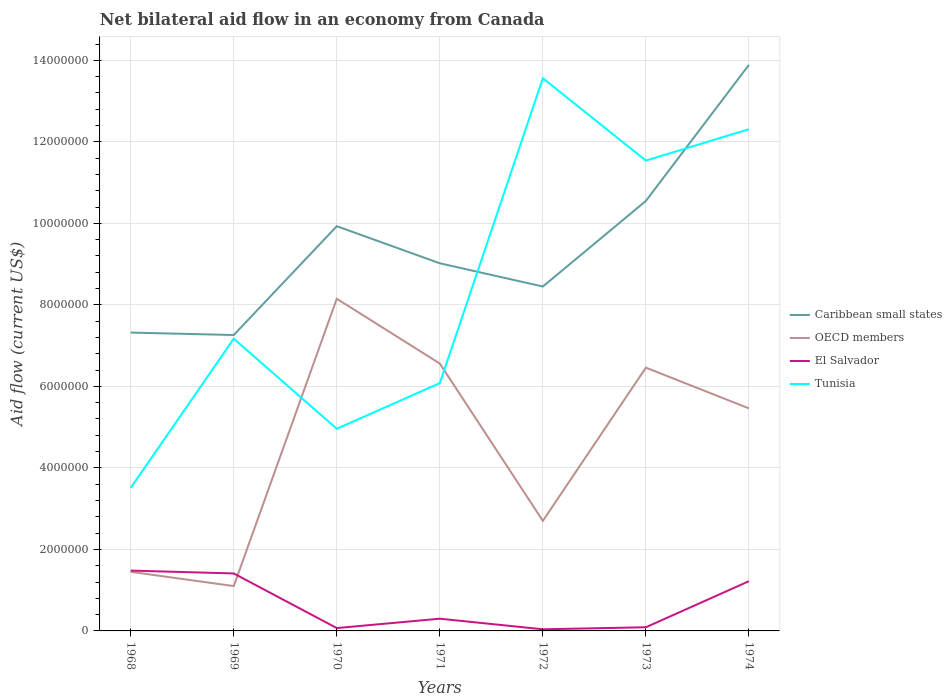How many different coloured lines are there?
Your answer should be very brief. 4. Does the line corresponding to El Salvador intersect with the line corresponding to Tunisia?
Your answer should be compact. No. Is the number of lines equal to the number of legend labels?
Give a very brief answer. Yes. Across all years, what is the maximum net bilateral aid flow in Tunisia?
Provide a succinct answer. 3.51e+06. In which year was the net bilateral aid flow in Tunisia maximum?
Make the answer very short. 1968. What is the total net bilateral aid flow in OECD members in the graph?
Provide a succinct answer. 1.00e+06. What is the difference between the highest and the second highest net bilateral aid flow in OECD members?
Provide a short and direct response. 7.05e+06. What is the difference between the highest and the lowest net bilateral aid flow in Caribbean small states?
Provide a short and direct response. 3. What is the difference between two consecutive major ticks on the Y-axis?
Your answer should be compact. 2.00e+06. Does the graph contain grids?
Offer a terse response. Yes. What is the title of the graph?
Give a very brief answer. Net bilateral aid flow in an economy from Canada. What is the label or title of the Y-axis?
Give a very brief answer. Aid flow (current US$). What is the Aid flow (current US$) of Caribbean small states in 1968?
Ensure brevity in your answer.  7.32e+06. What is the Aid flow (current US$) in OECD members in 1968?
Your answer should be very brief. 1.45e+06. What is the Aid flow (current US$) of El Salvador in 1968?
Make the answer very short. 1.48e+06. What is the Aid flow (current US$) of Tunisia in 1968?
Provide a succinct answer. 3.51e+06. What is the Aid flow (current US$) of Caribbean small states in 1969?
Offer a terse response. 7.26e+06. What is the Aid flow (current US$) of OECD members in 1969?
Provide a short and direct response. 1.10e+06. What is the Aid flow (current US$) of El Salvador in 1969?
Ensure brevity in your answer.  1.41e+06. What is the Aid flow (current US$) in Tunisia in 1969?
Your answer should be very brief. 7.17e+06. What is the Aid flow (current US$) of Caribbean small states in 1970?
Give a very brief answer. 9.93e+06. What is the Aid flow (current US$) in OECD members in 1970?
Offer a very short reply. 8.15e+06. What is the Aid flow (current US$) in El Salvador in 1970?
Ensure brevity in your answer.  7.00e+04. What is the Aid flow (current US$) of Tunisia in 1970?
Make the answer very short. 4.96e+06. What is the Aid flow (current US$) in Caribbean small states in 1971?
Offer a terse response. 9.02e+06. What is the Aid flow (current US$) in OECD members in 1971?
Provide a short and direct response. 6.56e+06. What is the Aid flow (current US$) in Tunisia in 1971?
Offer a very short reply. 6.08e+06. What is the Aid flow (current US$) in Caribbean small states in 1972?
Offer a very short reply. 8.45e+06. What is the Aid flow (current US$) in OECD members in 1972?
Make the answer very short. 2.70e+06. What is the Aid flow (current US$) in El Salvador in 1972?
Offer a very short reply. 4.00e+04. What is the Aid flow (current US$) of Tunisia in 1972?
Provide a succinct answer. 1.36e+07. What is the Aid flow (current US$) in Caribbean small states in 1973?
Keep it short and to the point. 1.06e+07. What is the Aid flow (current US$) of OECD members in 1973?
Offer a terse response. 6.46e+06. What is the Aid flow (current US$) in El Salvador in 1973?
Offer a terse response. 9.00e+04. What is the Aid flow (current US$) of Tunisia in 1973?
Keep it short and to the point. 1.15e+07. What is the Aid flow (current US$) of Caribbean small states in 1974?
Offer a terse response. 1.39e+07. What is the Aid flow (current US$) of OECD members in 1974?
Offer a terse response. 5.46e+06. What is the Aid flow (current US$) in El Salvador in 1974?
Your answer should be compact. 1.22e+06. What is the Aid flow (current US$) of Tunisia in 1974?
Give a very brief answer. 1.23e+07. Across all years, what is the maximum Aid flow (current US$) of Caribbean small states?
Ensure brevity in your answer.  1.39e+07. Across all years, what is the maximum Aid flow (current US$) of OECD members?
Offer a very short reply. 8.15e+06. Across all years, what is the maximum Aid flow (current US$) of El Salvador?
Your answer should be very brief. 1.48e+06. Across all years, what is the maximum Aid flow (current US$) in Tunisia?
Your response must be concise. 1.36e+07. Across all years, what is the minimum Aid flow (current US$) in Caribbean small states?
Offer a terse response. 7.26e+06. Across all years, what is the minimum Aid flow (current US$) of OECD members?
Your answer should be compact. 1.10e+06. Across all years, what is the minimum Aid flow (current US$) in Tunisia?
Your answer should be compact. 3.51e+06. What is the total Aid flow (current US$) of Caribbean small states in the graph?
Offer a terse response. 6.64e+07. What is the total Aid flow (current US$) in OECD members in the graph?
Provide a succinct answer. 3.19e+07. What is the total Aid flow (current US$) in El Salvador in the graph?
Give a very brief answer. 4.61e+06. What is the total Aid flow (current US$) of Tunisia in the graph?
Your answer should be very brief. 5.91e+07. What is the difference between the Aid flow (current US$) in Caribbean small states in 1968 and that in 1969?
Give a very brief answer. 6.00e+04. What is the difference between the Aid flow (current US$) in OECD members in 1968 and that in 1969?
Your answer should be very brief. 3.50e+05. What is the difference between the Aid flow (current US$) in Tunisia in 1968 and that in 1969?
Your answer should be very brief. -3.66e+06. What is the difference between the Aid flow (current US$) of Caribbean small states in 1968 and that in 1970?
Offer a very short reply. -2.61e+06. What is the difference between the Aid flow (current US$) of OECD members in 1968 and that in 1970?
Your response must be concise. -6.70e+06. What is the difference between the Aid flow (current US$) in El Salvador in 1968 and that in 1970?
Offer a terse response. 1.41e+06. What is the difference between the Aid flow (current US$) of Tunisia in 1968 and that in 1970?
Offer a terse response. -1.45e+06. What is the difference between the Aid flow (current US$) in Caribbean small states in 1968 and that in 1971?
Your answer should be very brief. -1.70e+06. What is the difference between the Aid flow (current US$) in OECD members in 1968 and that in 1971?
Give a very brief answer. -5.11e+06. What is the difference between the Aid flow (current US$) in El Salvador in 1968 and that in 1971?
Keep it short and to the point. 1.18e+06. What is the difference between the Aid flow (current US$) in Tunisia in 1968 and that in 1971?
Keep it short and to the point. -2.57e+06. What is the difference between the Aid flow (current US$) in Caribbean small states in 1968 and that in 1972?
Provide a succinct answer. -1.13e+06. What is the difference between the Aid flow (current US$) of OECD members in 1968 and that in 1972?
Keep it short and to the point. -1.25e+06. What is the difference between the Aid flow (current US$) of El Salvador in 1968 and that in 1972?
Offer a very short reply. 1.44e+06. What is the difference between the Aid flow (current US$) in Tunisia in 1968 and that in 1972?
Give a very brief answer. -1.00e+07. What is the difference between the Aid flow (current US$) in Caribbean small states in 1968 and that in 1973?
Provide a short and direct response. -3.23e+06. What is the difference between the Aid flow (current US$) in OECD members in 1968 and that in 1973?
Give a very brief answer. -5.01e+06. What is the difference between the Aid flow (current US$) of El Salvador in 1968 and that in 1973?
Provide a short and direct response. 1.39e+06. What is the difference between the Aid flow (current US$) in Tunisia in 1968 and that in 1973?
Give a very brief answer. -8.03e+06. What is the difference between the Aid flow (current US$) in Caribbean small states in 1968 and that in 1974?
Keep it short and to the point. -6.57e+06. What is the difference between the Aid flow (current US$) of OECD members in 1968 and that in 1974?
Give a very brief answer. -4.01e+06. What is the difference between the Aid flow (current US$) in El Salvador in 1968 and that in 1974?
Provide a succinct answer. 2.60e+05. What is the difference between the Aid flow (current US$) in Tunisia in 1968 and that in 1974?
Your answer should be very brief. -8.80e+06. What is the difference between the Aid flow (current US$) in Caribbean small states in 1969 and that in 1970?
Provide a succinct answer. -2.67e+06. What is the difference between the Aid flow (current US$) in OECD members in 1969 and that in 1970?
Offer a terse response. -7.05e+06. What is the difference between the Aid flow (current US$) in El Salvador in 1969 and that in 1970?
Your answer should be compact. 1.34e+06. What is the difference between the Aid flow (current US$) in Tunisia in 1969 and that in 1970?
Offer a very short reply. 2.21e+06. What is the difference between the Aid flow (current US$) in Caribbean small states in 1969 and that in 1971?
Ensure brevity in your answer.  -1.76e+06. What is the difference between the Aid flow (current US$) in OECD members in 1969 and that in 1971?
Your answer should be compact. -5.46e+06. What is the difference between the Aid flow (current US$) of El Salvador in 1969 and that in 1971?
Your answer should be compact. 1.11e+06. What is the difference between the Aid flow (current US$) in Tunisia in 1969 and that in 1971?
Your answer should be very brief. 1.09e+06. What is the difference between the Aid flow (current US$) of Caribbean small states in 1969 and that in 1972?
Provide a short and direct response. -1.19e+06. What is the difference between the Aid flow (current US$) of OECD members in 1969 and that in 1972?
Your answer should be very brief. -1.60e+06. What is the difference between the Aid flow (current US$) of El Salvador in 1969 and that in 1972?
Offer a terse response. 1.37e+06. What is the difference between the Aid flow (current US$) of Tunisia in 1969 and that in 1972?
Offer a very short reply. -6.39e+06. What is the difference between the Aid flow (current US$) of Caribbean small states in 1969 and that in 1973?
Your answer should be compact. -3.29e+06. What is the difference between the Aid flow (current US$) in OECD members in 1969 and that in 1973?
Make the answer very short. -5.36e+06. What is the difference between the Aid flow (current US$) of El Salvador in 1969 and that in 1973?
Keep it short and to the point. 1.32e+06. What is the difference between the Aid flow (current US$) of Tunisia in 1969 and that in 1973?
Provide a short and direct response. -4.37e+06. What is the difference between the Aid flow (current US$) in Caribbean small states in 1969 and that in 1974?
Offer a terse response. -6.63e+06. What is the difference between the Aid flow (current US$) in OECD members in 1969 and that in 1974?
Your response must be concise. -4.36e+06. What is the difference between the Aid flow (current US$) in Tunisia in 1969 and that in 1974?
Your answer should be compact. -5.14e+06. What is the difference between the Aid flow (current US$) in Caribbean small states in 1970 and that in 1971?
Your answer should be very brief. 9.10e+05. What is the difference between the Aid flow (current US$) in OECD members in 1970 and that in 1971?
Your answer should be very brief. 1.59e+06. What is the difference between the Aid flow (current US$) of Tunisia in 1970 and that in 1971?
Your answer should be very brief. -1.12e+06. What is the difference between the Aid flow (current US$) of Caribbean small states in 1970 and that in 1972?
Make the answer very short. 1.48e+06. What is the difference between the Aid flow (current US$) of OECD members in 1970 and that in 1972?
Keep it short and to the point. 5.45e+06. What is the difference between the Aid flow (current US$) in Tunisia in 1970 and that in 1972?
Your answer should be very brief. -8.60e+06. What is the difference between the Aid flow (current US$) of Caribbean small states in 1970 and that in 1973?
Offer a terse response. -6.20e+05. What is the difference between the Aid flow (current US$) of OECD members in 1970 and that in 1973?
Give a very brief answer. 1.69e+06. What is the difference between the Aid flow (current US$) of El Salvador in 1970 and that in 1973?
Give a very brief answer. -2.00e+04. What is the difference between the Aid flow (current US$) in Tunisia in 1970 and that in 1973?
Make the answer very short. -6.58e+06. What is the difference between the Aid flow (current US$) in Caribbean small states in 1970 and that in 1974?
Provide a succinct answer. -3.96e+06. What is the difference between the Aid flow (current US$) in OECD members in 1970 and that in 1974?
Offer a very short reply. 2.69e+06. What is the difference between the Aid flow (current US$) in El Salvador in 1970 and that in 1974?
Offer a terse response. -1.15e+06. What is the difference between the Aid flow (current US$) in Tunisia in 1970 and that in 1974?
Offer a terse response. -7.35e+06. What is the difference between the Aid flow (current US$) of Caribbean small states in 1971 and that in 1972?
Make the answer very short. 5.70e+05. What is the difference between the Aid flow (current US$) of OECD members in 1971 and that in 1972?
Your response must be concise. 3.86e+06. What is the difference between the Aid flow (current US$) in El Salvador in 1971 and that in 1972?
Your response must be concise. 2.60e+05. What is the difference between the Aid flow (current US$) of Tunisia in 1971 and that in 1972?
Provide a short and direct response. -7.48e+06. What is the difference between the Aid flow (current US$) of Caribbean small states in 1971 and that in 1973?
Make the answer very short. -1.53e+06. What is the difference between the Aid flow (current US$) of Tunisia in 1971 and that in 1973?
Give a very brief answer. -5.46e+06. What is the difference between the Aid flow (current US$) of Caribbean small states in 1971 and that in 1974?
Your response must be concise. -4.87e+06. What is the difference between the Aid flow (current US$) in OECD members in 1971 and that in 1974?
Provide a succinct answer. 1.10e+06. What is the difference between the Aid flow (current US$) of El Salvador in 1971 and that in 1974?
Provide a succinct answer. -9.20e+05. What is the difference between the Aid flow (current US$) in Tunisia in 1971 and that in 1974?
Give a very brief answer. -6.23e+06. What is the difference between the Aid flow (current US$) of Caribbean small states in 1972 and that in 1973?
Keep it short and to the point. -2.10e+06. What is the difference between the Aid flow (current US$) of OECD members in 1972 and that in 1973?
Your answer should be compact. -3.76e+06. What is the difference between the Aid flow (current US$) in El Salvador in 1972 and that in 1973?
Keep it short and to the point. -5.00e+04. What is the difference between the Aid flow (current US$) in Tunisia in 1972 and that in 1973?
Make the answer very short. 2.02e+06. What is the difference between the Aid flow (current US$) in Caribbean small states in 1972 and that in 1974?
Provide a succinct answer. -5.44e+06. What is the difference between the Aid flow (current US$) in OECD members in 1972 and that in 1974?
Provide a short and direct response. -2.76e+06. What is the difference between the Aid flow (current US$) of El Salvador in 1972 and that in 1974?
Your response must be concise. -1.18e+06. What is the difference between the Aid flow (current US$) in Tunisia in 1972 and that in 1974?
Make the answer very short. 1.25e+06. What is the difference between the Aid flow (current US$) of Caribbean small states in 1973 and that in 1974?
Ensure brevity in your answer.  -3.34e+06. What is the difference between the Aid flow (current US$) of El Salvador in 1973 and that in 1974?
Give a very brief answer. -1.13e+06. What is the difference between the Aid flow (current US$) in Tunisia in 1973 and that in 1974?
Keep it short and to the point. -7.70e+05. What is the difference between the Aid flow (current US$) of Caribbean small states in 1968 and the Aid flow (current US$) of OECD members in 1969?
Keep it short and to the point. 6.22e+06. What is the difference between the Aid flow (current US$) in Caribbean small states in 1968 and the Aid flow (current US$) in El Salvador in 1969?
Make the answer very short. 5.91e+06. What is the difference between the Aid flow (current US$) of OECD members in 1968 and the Aid flow (current US$) of Tunisia in 1969?
Make the answer very short. -5.72e+06. What is the difference between the Aid flow (current US$) in El Salvador in 1968 and the Aid flow (current US$) in Tunisia in 1969?
Your response must be concise. -5.69e+06. What is the difference between the Aid flow (current US$) of Caribbean small states in 1968 and the Aid flow (current US$) of OECD members in 1970?
Provide a short and direct response. -8.30e+05. What is the difference between the Aid flow (current US$) in Caribbean small states in 1968 and the Aid flow (current US$) in El Salvador in 1970?
Ensure brevity in your answer.  7.25e+06. What is the difference between the Aid flow (current US$) of Caribbean small states in 1968 and the Aid flow (current US$) of Tunisia in 1970?
Your answer should be very brief. 2.36e+06. What is the difference between the Aid flow (current US$) of OECD members in 1968 and the Aid flow (current US$) of El Salvador in 1970?
Ensure brevity in your answer.  1.38e+06. What is the difference between the Aid flow (current US$) of OECD members in 1968 and the Aid flow (current US$) of Tunisia in 1970?
Ensure brevity in your answer.  -3.51e+06. What is the difference between the Aid flow (current US$) of El Salvador in 1968 and the Aid flow (current US$) of Tunisia in 1970?
Your answer should be compact. -3.48e+06. What is the difference between the Aid flow (current US$) of Caribbean small states in 1968 and the Aid flow (current US$) of OECD members in 1971?
Your answer should be very brief. 7.60e+05. What is the difference between the Aid flow (current US$) in Caribbean small states in 1968 and the Aid flow (current US$) in El Salvador in 1971?
Give a very brief answer. 7.02e+06. What is the difference between the Aid flow (current US$) in Caribbean small states in 1968 and the Aid flow (current US$) in Tunisia in 1971?
Provide a short and direct response. 1.24e+06. What is the difference between the Aid flow (current US$) of OECD members in 1968 and the Aid flow (current US$) of El Salvador in 1971?
Offer a very short reply. 1.15e+06. What is the difference between the Aid flow (current US$) of OECD members in 1968 and the Aid flow (current US$) of Tunisia in 1971?
Provide a succinct answer. -4.63e+06. What is the difference between the Aid flow (current US$) of El Salvador in 1968 and the Aid flow (current US$) of Tunisia in 1971?
Your response must be concise. -4.60e+06. What is the difference between the Aid flow (current US$) in Caribbean small states in 1968 and the Aid flow (current US$) in OECD members in 1972?
Your response must be concise. 4.62e+06. What is the difference between the Aid flow (current US$) of Caribbean small states in 1968 and the Aid flow (current US$) of El Salvador in 1972?
Offer a terse response. 7.28e+06. What is the difference between the Aid flow (current US$) in Caribbean small states in 1968 and the Aid flow (current US$) in Tunisia in 1972?
Your response must be concise. -6.24e+06. What is the difference between the Aid flow (current US$) in OECD members in 1968 and the Aid flow (current US$) in El Salvador in 1972?
Provide a succinct answer. 1.41e+06. What is the difference between the Aid flow (current US$) of OECD members in 1968 and the Aid flow (current US$) of Tunisia in 1972?
Your answer should be very brief. -1.21e+07. What is the difference between the Aid flow (current US$) in El Salvador in 1968 and the Aid flow (current US$) in Tunisia in 1972?
Provide a succinct answer. -1.21e+07. What is the difference between the Aid flow (current US$) in Caribbean small states in 1968 and the Aid flow (current US$) in OECD members in 1973?
Offer a very short reply. 8.60e+05. What is the difference between the Aid flow (current US$) of Caribbean small states in 1968 and the Aid flow (current US$) of El Salvador in 1973?
Your answer should be compact. 7.23e+06. What is the difference between the Aid flow (current US$) in Caribbean small states in 1968 and the Aid flow (current US$) in Tunisia in 1973?
Your answer should be very brief. -4.22e+06. What is the difference between the Aid flow (current US$) in OECD members in 1968 and the Aid flow (current US$) in El Salvador in 1973?
Keep it short and to the point. 1.36e+06. What is the difference between the Aid flow (current US$) of OECD members in 1968 and the Aid flow (current US$) of Tunisia in 1973?
Ensure brevity in your answer.  -1.01e+07. What is the difference between the Aid flow (current US$) in El Salvador in 1968 and the Aid flow (current US$) in Tunisia in 1973?
Your answer should be very brief. -1.01e+07. What is the difference between the Aid flow (current US$) of Caribbean small states in 1968 and the Aid flow (current US$) of OECD members in 1974?
Ensure brevity in your answer.  1.86e+06. What is the difference between the Aid flow (current US$) in Caribbean small states in 1968 and the Aid flow (current US$) in El Salvador in 1974?
Your answer should be very brief. 6.10e+06. What is the difference between the Aid flow (current US$) in Caribbean small states in 1968 and the Aid flow (current US$) in Tunisia in 1974?
Offer a terse response. -4.99e+06. What is the difference between the Aid flow (current US$) of OECD members in 1968 and the Aid flow (current US$) of El Salvador in 1974?
Your answer should be compact. 2.30e+05. What is the difference between the Aid flow (current US$) in OECD members in 1968 and the Aid flow (current US$) in Tunisia in 1974?
Your answer should be very brief. -1.09e+07. What is the difference between the Aid flow (current US$) in El Salvador in 1968 and the Aid flow (current US$) in Tunisia in 1974?
Make the answer very short. -1.08e+07. What is the difference between the Aid flow (current US$) of Caribbean small states in 1969 and the Aid flow (current US$) of OECD members in 1970?
Your answer should be compact. -8.90e+05. What is the difference between the Aid flow (current US$) in Caribbean small states in 1969 and the Aid flow (current US$) in El Salvador in 1970?
Give a very brief answer. 7.19e+06. What is the difference between the Aid flow (current US$) in Caribbean small states in 1969 and the Aid flow (current US$) in Tunisia in 1970?
Offer a very short reply. 2.30e+06. What is the difference between the Aid flow (current US$) of OECD members in 1969 and the Aid flow (current US$) of El Salvador in 1970?
Your answer should be very brief. 1.03e+06. What is the difference between the Aid flow (current US$) of OECD members in 1969 and the Aid flow (current US$) of Tunisia in 1970?
Ensure brevity in your answer.  -3.86e+06. What is the difference between the Aid flow (current US$) in El Salvador in 1969 and the Aid flow (current US$) in Tunisia in 1970?
Offer a terse response. -3.55e+06. What is the difference between the Aid flow (current US$) of Caribbean small states in 1969 and the Aid flow (current US$) of OECD members in 1971?
Offer a very short reply. 7.00e+05. What is the difference between the Aid flow (current US$) in Caribbean small states in 1969 and the Aid flow (current US$) in El Salvador in 1971?
Your answer should be compact. 6.96e+06. What is the difference between the Aid flow (current US$) in Caribbean small states in 1969 and the Aid flow (current US$) in Tunisia in 1971?
Your response must be concise. 1.18e+06. What is the difference between the Aid flow (current US$) in OECD members in 1969 and the Aid flow (current US$) in Tunisia in 1971?
Keep it short and to the point. -4.98e+06. What is the difference between the Aid flow (current US$) in El Salvador in 1969 and the Aid flow (current US$) in Tunisia in 1971?
Ensure brevity in your answer.  -4.67e+06. What is the difference between the Aid flow (current US$) of Caribbean small states in 1969 and the Aid flow (current US$) of OECD members in 1972?
Your answer should be very brief. 4.56e+06. What is the difference between the Aid flow (current US$) of Caribbean small states in 1969 and the Aid flow (current US$) of El Salvador in 1972?
Your answer should be compact. 7.22e+06. What is the difference between the Aid flow (current US$) in Caribbean small states in 1969 and the Aid flow (current US$) in Tunisia in 1972?
Your response must be concise. -6.30e+06. What is the difference between the Aid flow (current US$) of OECD members in 1969 and the Aid flow (current US$) of El Salvador in 1972?
Your answer should be compact. 1.06e+06. What is the difference between the Aid flow (current US$) in OECD members in 1969 and the Aid flow (current US$) in Tunisia in 1972?
Ensure brevity in your answer.  -1.25e+07. What is the difference between the Aid flow (current US$) of El Salvador in 1969 and the Aid flow (current US$) of Tunisia in 1972?
Ensure brevity in your answer.  -1.22e+07. What is the difference between the Aid flow (current US$) of Caribbean small states in 1969 and the Aid flow (current US$) of El Salvador in 1973?
Your answer should be compact. 7.17e+06. What is the difference between the Aid flow (current US$) in Caribbean small states in 1969 and the Aid flow (current US$) in Tunisia in 1973?
Provide a succinct answer. -4.28e+06. What is the difference between the Aid flow (current US$) of OECD members in 1969 and the Aid flow (current US$) of El Salvador in 1973?
Give a very brief answer. 1.01e+06. What is the difference between the Aid flow (current US$) in OECD members in 1969 and the Aid flow (current US$) in Tunisia in 1973?
Offer a terse response. -1.04e+07. What is the difference between the Aid flow (current US$) of El Salvador in 1969 and the Aid flow (current US$) of Tunisia in 1973?
Make the answer very short. -1.01e+07. What is the difference between the Aid flow (current US$) in Caribbean small states in 1969 and the Aid flow (current US$) in OECD members in 1974?
Provide a short and direct response. 1.80e+06. What is the difference between the Aid flow (current US$) in Caribbean small states in 1969 and the Aid flow (current US$) in El Salvador in 1974?
Offer a very short reply. 6.04e+06. What is the difference between the Aid flow (current US$) of Caribbean small states in 1969 and the Aid flow (current US$) of Tunisia in 1974?
Offer a very short reply. -5.05e+06. What is the difference between the Aid flow (current US$) in OECD members in 1969 and the Aid flow (current US$) in Tunisia in 1974?
Make the answer very short. -1.12e+07. What is the difference between the Aid flow (current US$) of El Salvador in 1969 and the Aid flow (current US$) of Tunisia in 1974?
Your answer should be very brief. -1.09e+07. What is the difference between the Aid flow (current US$) of Caribbean small states in 1970 and the Aid flow (current US$) of OECD members in 1971?
Offer a very short reply. 3.37e+06. What is the difference between the Aid flow (current US$) of Caribbean small states in 1970 and the Aid flow (current US$) of El Salvador in 1971?
Your answer should be very brief. 9.63e+06. What is the difference between the Aid flow (current US$) in Caribbean small states in 1970 and the Aid flow (current US$) in Tunisia in 1971?
Ensure brevity in your answer.  3.85e+06. What is the difference between the Aid flow (current US$) of OECD members in 1970 and the Aid flow (current US$) of El Salvador in 1971?
Your answer should be compact. 7.85e+06. What is the difference between the Aid flow (current US$) in OECD members in 1970 and the Aid flow (current US$) in Tunisia in 1971?
Your answer should be very brief. 2.07e+06. What is the difference between the Aid flow (current US$) of El Salvador in 1970 and the Aid flow (current US$) of Tunisia in 1971?
Your answer should be very brief. -6.01e+06. What is the difference between the Aid flow (current US$) in Caribbean small states in 1970 and the Aid flow (current US$) in OECD members in 1972?
Offer a very short reply. 7.23e+06. What is the difference between the Aid flow (current US$) of Caribbean small states in 1970 and the Aid flow (current US$) of El Salvador in 1972?
Give a very brief answer. 9.89e+06. What is the difference between the Aid flow (current US$) in Caribbean small states in 1970 and the Aid flow (current US$) in Tunisia in 1972?
Your answer should be compact. -3.63e+06. What is the difference between the Aid flow (current US$) in OECD members in 1970 and the Aid flow (current US$) in El Salvador in 1972?
Ensure brevity in your answer.  8.11e+06. What is the difference between the Aid flow (current US$) in OECD members in 1970 and the Aid flow (current US$) in Tunisia in 1972?
Your response must be concise. -5.41e+06. What is the difference between the Aid flow (current US$) of El Salvador in 1970 and the Aid flow (current US$) of Tunisia in 1972?
Keep it short and to the point. -1.35e+07. What is the difference between the Aid flow (current US$) of Caribbean small states in 1970 and the Aid flow (current US$) of OECD members in 1973?
Ensure brevity in your answer.  3.47e+06. What is the difference between the Aid flow (current US$) of Caribbean small states in 1970 and the Aid flow (current US$) of El Salvador in 1973?
Provide a succinct answer. 9.84e+06. What is the difference between the Aid flow (current US$) in Caribbean small states in 1970 and the Aid flow (current US$) in Tunisia in 1973?
Your answer should be compact. -1.61e+06. What is the difference between the Aid flow (current US$) in OECD members in 1970 and the Aid flow (current US$) in El Salvador in 1973?
Your answer should be compact. 8.06e+06. What is the difference between the Aid flow (current US$) in OECD members in 1970 and the Aid flow (current US$) in Tunisia in 1973?
Your answer should be compact. -3.39e+06. What is the difference between the Aid flow (current US$) of El Salvador in 1970 and the Aid flow (current US$) of Tunisia in 1973?
Provide a succinct answer. -1.15e+07. What is the difference between the Aid flow (current US$) in Caribbean small states in 1970 and the Aid flow (current US$) in OECD members in 1974?
Your answer should be very brief. 4.47e+06. What is the difference between the Aid flow (current US$) of Caribbean small states in 1970 and the Aid flow (current US$) of El Salvador in 1974?
Offer a very short reply. 8.71e+06. What is the difference between the Aid flow (current US$) in Caribbean small states in 1970 and the Aid flow (current US$) in Tunisia in 1974?
Keep it short and to the point. -2.38e+06. What is the difference between the Aid flow (current US$) in OECD members in 1970 and the Aid flow (current US$) in El Salvador in 1974?
Offer a terse response. 6.93e+06. What is the difference between the Aid flow (current US$) in OECD members in 1970 and the Aid flow (current US$) in Tunisia in 1974?
Your response must be concise. -4.16e+06. What is the difference between the Aid flow (current US$) of El Salvador in 1970 and the Aid flow (current US$) of Tunisia in 1974?
Your answer should be compact. -1.22e+07. What is the difference between the Aid flow (current US$) in Caribbean small states in 1971 and the Aid flow (current US$) in OECD members in 1972?
Give a very brief answer. 6.32e+06. What is the difference between the Aid flow (current US$) of Caribbean small states in 1971 and the Aid flow (current US$) of El Salvador in 1972?
Make the answer very short. 8.98e+06. What is the difference between the Aid flow (current US$) in Caribbean small states in 1971 and the Aid flow (current US$) in Tunisia in 1972?
Give a very brief answer. -4.54e+06. What is the difference between the Aid flow (current US$) of OECD members in 1971 and the Aid flow (current US$) of El Salvador in 1972?
Your answer should be very brief. 6.52e+06. What is the difference between the Aid flow (current US$) of OECD members in 1971 and the Aid flow (current US$) of Tunisia in 1972?
Make the answer very short. -7.00e+06. What is the difference between the Aid flow (current US$) in El Salvador in 1971 and the Aid flow (current US$) in Tunisia in 1972?
Offer a very short reply. -1.33e+07. What is the difference between the Aid flow (current US$) in Caribbean small states in 1971 and the Aid flow (current US$) in OECD members in 1973?
Provide a short and direct response. 2.56e+06. What is the difference between the Aid flow (current US$) in Caribbean small states in 1971 and the Aid flow (current US$) in El Salvador in 1973?
Make the answer very short. 8.93e+06. What is the difference between the Aid flow (current US$) of Caribbean small states in 1971 and the Aid flow (current US$) of Tunisia in 1973?
Provide a succinct answer. -2.52e+06. What is the difference between the Aid flow (current US$) of OECD members in 1971 and the Aid flow (current US$) of El Salvador in 1973?
Keep it short and to the point. 6.47e+06. What is the difference between the Aid flow (current US$) of OECD members in 1971 and the Aid flow (current US$) of Tunisia in 1973?
Give a very brief answer. -4.98e+06. What is the difference between the Aid flow (current US$) of El Salvador in 1971 and the Aid flow (current US$) of Tunisia in 1973?
Your answer should be very brief. -1.12e+07. What is the difference between the Aid flow (current US$) of Caribbean small states in 1971 and the Aid flow (current US$) of OECD members in 1974?
Offer a very short reply. 3.56e+06. What is the difference between the Aid flow (current US$) in Caribbean small states in 1971 and the Aid flow (current US$) in El Salvador in 1974?
Provide a succinct answer. 7.80e+06. What is the difference between the Aid flow (current US$) in Caribbean small states in 1971 and the Aid flow (current US$) in Tunisia in 1974?
Your answer should be very brief. -3.29e+06. What is the difference between the Aid flow (current US$) in OECD members in 1971 and the Aid flow (current US$) in El Salvador in 1974?
Your answer should be compact. 5.34e+06. What is the difference between the Aid flow (current US$) in OECD members in 1971 and the Aid flow (current US$) in Tunisia in 1974?
Your answer should be very brief. -5.75e+06. What is the difference between the Aid flow (current US$) of El Salvador in 1971 and the Aid flow (current US$) of Tunisia in 1974?
Your response must be concise. -1.20e+07. What is the difference between the Aid flow (current US$) of Caribbean small states in 1972 and the Aid flow (current US$) of OECD members in 1973?
Make the answer very short. 1.99e+06. What is the difference between the Aid flow (current US$) of Caribbean small states in 1972 and the Aid flow (current US$) of El Salvador in 1973?
Give a very brief answer. 8.36e+06. What is the difference between the Aid flow (current US$) in Caribbean small states in 1972 and the Aid flow (current US$) in Tunisia in 1973?
Offer a very short reply. -3.09e+06. What is the difference between the Aid flow (current US$) of OECD members in 1972 and the Aid flow (current US$) of El Salvador in 1973?
Your answer should be compact. 2.61e+06. What is the difference between the Aid flow (current US$) of OECD members in 1972 and the Aid flow (current US$) of Tunisia in 1973?
Your answer should be compact. -8.84e+06. What is the difference between the Aid flow (current US$) of El Salvador in 1972 and the Aid flow (current US$) of Tunisia in 1973?
Provide a succinct answer. -1.15e+07. What is the difference between the Aid flow (current US$) in Caribbean small states in 1972 and the Aid flow (current US$) in OECD members in 1974?
Offer a terse response. 2.99e+06. What is the difference between the Aid flow (current US$) of Caribbean small states in 1972 and the Aid flow (current US$) of El Salvador in 1974?
Offer a terse response. 7.23e+06. What is the difference between the Aid flow (current US$) of Caribbean small states in 1972 and the Aid flow (current US$) of Tunisia in 1974?
Your answer should be compact. -3.86e+06. What is the difference between the Aid flow (current US$) in OECD members in 1972 and the Aid flow (current US$) in El Salvador in 1974?
Your answer should be compact. 1.48e+06. What is the difference between the Aid flow (current US$) in OECD members in 1972 and the Aid flow (current US$) in Tunisia in 1974?
Provide a short and direct response. -9.61e+06. What is the difference between the Aid flow (current US$) of El Salvador in 1972 and the Aid flow (current US$) of Tunisia in 1974?
Give a very brief answer. -1.23e+07. What is the difference between the Aid flow (current US$) of Caribbean small states in 1973 and the Aid flow (current US$) of OECD members in 1974?
Keep it short and to the point. 5.09e+06. What is the difference between the Aid flow (current US$) of Caribbean small states in 1973 and the Aid flow (current US$) of El Salvador in 1974?
Provide a succinct answer. 9.33e+06. What is the difference between the Aid flow (current US$) in Caribbean small states in 1973 and the Aid flow (current US$) in Tunisia in 1974?
Give a very brief answer. -1.76e+06. What is the difference between the Aid flow (current US$) of OECD members in 1973 and the Aid flow (current US$) of El Salvador in 1974?
Give a very brief answer. 5.24e+06. What is the difference between the Aid flow (current US$) of OECD members in 1973 and the Aid flow (current US$) of Tunisia in 1974?
Your answer should be compact. -5.85e+06. What is the difference between the Aid flow (current US$) of El Salvador in 1973 and the Aid flow (current US$) of Tunisia in 1974?
Keep it short and to the point. -1.22e+07. What is the average Aid flow (current US$) in Caribbean small states per year?
Ensure brevity in your answer.  9.49e+06. What is the average Aid flow (current US$) of OECD members per year?
Offer a terse response. 4.55e+06. What is the average Aid flow (current US$) of El Salvador per year?
Your answer should be compact. 6.59e+05. What is the average Aid flow (current US$) in Tunisia per year?
Ensure brevity in your answer.  8.45e+06. In the year 1968, what is the difference between the Aid flow (current US$) of Caribbean small states and Aid flow (current US$) of OECD members?
Ensure brevity in your answer.  5.87e+06. In the year 1968, what is the difference between the Aid flow (current US$) of Caribbean small states and Aid flow (current US$) of El Salvador?
Your answer should be compact. 5.84e+06. In the year 1968, what is the difference between the Aid flow (current US$) of Caribbean small states and Aid flow (current US$) of Tunisia?
Provide a short and direct response. 3.81e+06. In the year 1968, what is the difference between the Aid flow (current US$) of OECD members and Aid flow (current US$) of El Salvador?
Offer a terse response. -3.00e+04. In the year 1968, what is the difference between the Aid flow (current US$) of OECD members and Aid flow (current US$) of Tunisia?
Provide a short and direct response. -2.06e+06. In the year 1968, what is the difference between the Aid flow (current US$) of El Salvador and Aid flow (current US$) of Tunisia?
Ensure brevity in your answer.  -2.03e+06. In the year 1969, what is the difference between the Aid flow (current US$) of Caribbean small states and Aid flow (current US$) of OECD members?
Make the answer very short. 6.16e+06. In the year 1969, what is the difference between the Aid flow (current US$) of Caribbean small states and Aid flow (current US$) of El Salvador?
Provide a succinct answer. 5.85e+06. In the year 1969, what is the difference between the Aid flow (current US$) of OECD members and Aid flow (current US$) of El Salvador?
Offer a very short reply. -3.10e+05. In the year 1969, what is the difference between the Aid flow (current US$) in OECD members and Aid flow (current US$) in Tunisia?
Your answer should be compact. -6.07e+06. In the year 1969, what is the difference between the Aid flow (current US$) in El Salvador and Aid flow (current US$) in Tunisia?
Provide a short and direct response. -5.76e+06. In the year 1970, what is the difference between the Aid flow (current US$) of Caribbean small states and Aid flow (current US$) of OECD members?
Your response must be concise. 1.78e+06. In the year 1970, what is the difference between the Aid flow (current US$) of Caribbean small states and Aid flow (current US$) of El Salvador?
Give a very brief answer. 9.86e+06. In the year 1970, what is the difference between the Aid flow (current US$) in Caribbean small states and Aid flow (current US$) in Tunisia?
Give a very brief answer. 4.97e+06. In the year 1970, what is the difference between the Aid flow (current US$) of OECD members and Aid flow (current US$) of El Salvador?
Ensure brevity in your answer.  8.08e+06. In the year 1970, what is the difference between the Aid flow (current US$) of OECD members and Aid flow (current US$) of Tunisia?
Keep it short and to the point. 3.19e+06. In the year 1970, what is the difference between the Aid flow (current US$) in El Salvador and Aid flow (current US$) in Tunisia?
Your answer should be very brief. -4.89e+06. In the year 1971, what is the difference between the Aid flow (current US$) of Caribbean small states and Aid flow (current US$) of OECD members?
Keep it short and to the point. 2.46e+06. In the year 1971, what is the difference between the Aid flow (current US$) of Caribbean small states and Aid flow (current US$) of El Salvador?
Provide a short and direct response. 8.72e+06. In the year 1971, what is the difference between the Aid flow (current US$) in Caribbean small states and Aid flow (current US$) in Tunisia?
Keep it short and to the point. 2.94e+06. In the year 1971, what is the difference between the Aid flow (current US$) of OECD members and Aid flow (current US$) of El Salvador?
Provide a succinct answer. 6.26e+06. In the year 1971, what is the difference between the Aid flow (current US$) of El Salvador and Aid flow (current US$) of Tunisia?
Keep it short and to the point. -5.78e+06. In the year 1972, what is the difference between the Aid flow (current US$) in Caribbean small states and Aid flow (current US$) in OECD members?
Provide a succinct answer. 5.75e+06. In the year 1972, what is the difference between the Aid flow (current US$) in Caribbean small states and Aid flow (current US$) in El Salvador?
Your answer should be very brief. 8.41e+06. In the year 1972, what is the difference between the Aid flow (current US$) of Caribbean small states and Aid flow (current US$) of Tunisia?
Provide a short and direct response. -5.11e+06. In the year 1972, what is the difference between the Aid flow (current US$) of OECD members and Aid flow (current US$) of El Salvador?
Your answer should be compact. 2.66e+06. In the year 1972, what is the difference between the Aid flow (current US$) of OECD members and Aid flow (current US$) of Tunisia?
Your answer should be compact. -1.09e+07. In the year 1972, what is the difference between the Aid flow (current US$) of El Salvador and Aid flow (current US$) of Tunisia?
Give a very brief answer. -1.35e+07. In the year 1973, what is the difference between the Aid flow (current US$) of Caribbean small states and Aid flow (current US$) of OECD members?
Offer a very short reply. 4.09e+06. In the year 1973, what is the difference between the Aid flow (current US$) in Caribbean small states and Aid flow (current US$) in El Salvador?
Your response must be concise. 1.05e+07. In the year 1973, what is the difference between the Aid flow (current US$) of Caribbean small states and Aid flow (current US$) of Tunisia?
Make the answer very short. -9.90e+05. In the year 1973, what is the difference between the Aid flow (current US$) of OECD members and Aid flow (current US$) of El Salvador?
Keep it short and to the point. 6.37e+06. In the year 1973, what is the difference between the Aid flow (current US$) in OECD members and Aid flow (current US$) in Tunisia?
Provide a succinct answer. -5.08e+06. In the year 1973, what is the difference between the Aid flow (current US$) in El Salvador and Aid flow (current US$) in Tunisia?
Ensure brevity in your answer.  -1.14e+07. In the year 1974, what is the difference between the Aid flow (current US$) in Caribbean small states and Aid flow (current US$) in OECD members?
Keep it short and to the point. 8.43e+06. In the year 1974, what is the difference between the Aid flow (current US$) of Caribbean small states and Aid flow (current US$) of El Salvador?
Ensure brevity in your answer.  1.27e+07. In the year 1974, what is the difference between the Aid flow (current US$) in Caribbean small states and Aid flow (current US$) in Tunisia?
Offer a terse response. 1.58e+06. In the year 1974, what is the difference between the Aid flow (current US$) of OECD members and Aid flow (current US$) of El Salvador?
Provide a succinct answer. 4.24e+06. In the year 1974, what is the difference between the Aid flow (current US$) of OECD members and Aid flow (current US$) of Tunisia?
Make the answer very short. -6.85e+06. In the year 1974, what is the difference between the Aid flow (current US$) in El Salvador and Aid flow (current US$) in Tunisia?
Offer a very short reply. -1.11e+07. What is the ratio of the Aid flow (current US$) of Caribbean small states in 1968 to that in 1969?
Provide a short and direct response. 1.01. What is the ratio of the Aid flow (current US$) of OECD members in 1968 to that in 1969?
Provide a short and direct response. 1.32. What is the ratio of the Aid flow (current US$) in El Salvador in 1968 to that in 1969?
Provide a short and direct response. 1.05. What is the ratio of the Aid flow (current US$) in Tunisia in 1968 to that in 1969?
Offer a terse response. 0.49. What is the ratio of the Aid flow (current US$) in Caribbean small states in 1968 to that in 1970?
Provide a succinct answer. 0.74. What is the ratio of the Aid flow (current US$) in OECD members in 1968 to that in 1970?
Your answer should be very brief. 0.18. What is the ratio of the Aid flow (current US$) in El Salvador in 1968 to that in 1970?
Your response must be concise. 21.14. What is the ratio of the Aid flow (current US$) in Tunisia in 1968 to that in 1970?
Offer a terse response. 0.71. What is the ratio of the Aid flow (current US$) of Caribbean small states in 1968 to that in 1971?
Offer a terse response. 0.81. What is the ratio of the Aid flow (current US$) of OECD members in 1968 to that in 1971?
Make the answer very short. 0.22. What is the ratio of the Aid flow (current US$) in El Salvador in 1968 to that in 1971?
Provide a succinct answer. 4.93. What is the ratio of the Aid flow (current US$) in Tunisia in 1968 to that in 1971?
Make the answer very short. 0.58. What is the ratio of the Aid flow (current US$) of Caribbean small states in 1968 to that in 1972?
Provide a short and direct response. 0.87. What is the ratio of the Aid flow (current US$) of OECD members in 1968 to that in 1972?
Your response must be concise. 0.54. What is the ratio of the Aid flow (current US$) of El Salvador in 1968 to that in 1972?
Your answer should be very brief. 37. What is the ratio of the Aid flow (current US$) in Tunisia in 1968 to that in 1972?
Provide a succinct answer. 0.26. What is the ratio of the Aid flow (current US$) in Caribbean small states in 1968 to that in 1973?
Offer a very short reply. 0.69. What is the ratio of the Aid flow (current US$) in OECD members in 1968 to that in 1973?
Keep it short and to the point. 0.22. What is the ratio of the Aid flow (current US$) in El Salvador in 1968 to that in 1973?
Your answer should be compact. 16.44. What is the ratio of the Aid flow (current US$) in Tunisia in 1968 to that in 1973?
Make the answer very short. 0.3. What is the ratio of the Aid flow (current US$) of Caribbean small states in 1968 to that in 1974?
Ensure brevity in your answer.  0.53. What is the ratio of the Aid flow (current US$) in OECD members in 1968 to that in 1974?
Make the answer very short. 0.27. What is the ratio of the Aid flow (current US$) in El Salvador in 1968 to that in 1974?
Keep it short and to the point. 1.21. What is the ratio of the Aid flow (current US$) in Tunisia in 1968 to that in 1974?
Ensure brevity in your answer.  0.29. What is the ratio of the Aid flow (current US$) of Caribbean small states in 1969 to that in 1970?
Keep it short and to the point. 0.73. What is the ratio of the Aid flow (current US$) in OECD members in 1969 to that in 1970?
Offer a terse response. 0.14. What is the ratio of the Aid flow (current US$) of El Salvador in 1969 to that in 1970?
Offer a terse response. 20.14. What is the ratio of the Aid flow (current US$) of Tunisia in 1969 to that in 1970?
Your answer should be very brief. 1.45. What is the ratio of the Aid flow (current US$) of Caribbean small states in 1969 to that in 1971?
Provide a succinct answer. 0.8. What is the ratio of the Aid flow (current US$) of OECD members in 1969 to that in 1971?
Your answer should be compact. 0.17. What is the ratio of the Aid flow (current US$) in El Salvador in 1969 to that in 1971?
Provide a short and direct response. 4.7. What is the ratio of the Aid flow (current US$) in Tunisia in 1969 to that in 1971?
Your answer should be very brief. 1.18. What is the ratio of the Aid flow (current US$) of Caribbean small states in 1969 to that in 1972?
Offer a terse response. 0.86. What is the ratio of the Aid flow (current US$) of OECD members in 1969 to that in 1972?
Offer a terse response. 0.41. What is the ratio of the Aid flow (current US$) of El Salvador in 1969 to that in 1972?
Your answer should be compact. 35.25. What is the ratio of the Aid flow (current US$) of Tunisia in 1969 to that in 1972?
Provide a short and direct response. 0.53. What is the ratio of the Aid flow (current US$) in Caribbean small states in 1969 to that in 1973?
Your answer should be very brief. 0.69. What is the ratio of the Aid flow (current US$) of OECD members in 1969 to that in 1973?
Keep it short and to the point. 0.17. What is the ratio of the Aid flow (current US$) of El Salvador in 1969 to that in 1973?
Provide a short and direct response. 15.67. What is the ratio of the Aid flow (current US$) in Tunisia in 1969 to that in 1973?
Provide a succinct answer. 0.62. What is the ratio of the Aid flow (current US$) in Caribbean small states in 1969 to that in 1974?
Provide a short and direct response. 0.52. What is the ratio of the Aid flow (current US$) in OECD members in 1969 to that in 1974?
Offer a terse response. 0.2. What is the ratio of the Aid flow (current US$) of El Salvador in 1969 to that in 1974?
Your answer should be compact. 1.16. What is the ratio of the Aid flow (current US$) of Tunisia in 1969 to that in 1974?
Your response must be concise. 0.58. What is the ratio of the Aid flow (current US$) in Caribbean small states in 1970 to that in 1971?
Your answer should be compact. 1.1. What is the ratio of the Aid flow (current US$) in OECD members in 1970 to that in 1971?
Your answer should be very brief. 1.24. What is the ratio of the Aid flow (current US$) in El Salvador in 1970 to that in 1971?
Your response must be concise. 0.23. What is the ratio of the Aid flow (current US$) of Tunisia in 1970 to that in 1971?
Offer a terse response. 0.82. What is the ratio of the Aid flow (current US$) of Caribbean small states in 1970 to that in 1972?
Provide a succinct answer. 1.18. What is the ratio of the Aid flow (current US$) of OECD members in 1970 to that in 1972?
Your response must be concise. 3.02. What is the ratio of the Aid flow (current US$) of Tunisia in 1970 to that in 1972?
Keep it short and to the point. 0.37. What is the ratio of the Aid flow (current US$) of Caribbean small states in 1970 to that in 1973?
Your response must be concise. 0.94. What is the ratio of the Aid flow (current US$) in OECD members in 1970 to that in 1973?
Offer a very short reply. 1.26. What is the ratio of the Aid flow (current US$) in El Salvador in 1970 to that in 1973?
Provide a short and direct response. 0.78. What is the ratio of the Aid flow (current US$) in Tunisia in 1970 to that in 1973?
Ensure brevity in your answer.  0.43. What is the ratio of the Aid flow (current US$) in Caribbean small states in 1970 to that in 1974?
Keep it short and to the point. 0.71. What is the ratio of the Aid flow (current US$) in OECD members in 1970 to that in 1974?
Your answer should be very brief. 1.49. What is the ratio of the Aid flow (current US$) of El Salvador in 1970 to that in 1974?
Your response must be concise. 0.06. What is the ratio of the Aid flow (current US$) of Tunisia in 1970 to that in 1974?
Your response must be concise. 0.4. What is the ratio of the Aid flow (current US$) of Caribbean small states in 1971 to that in 1972?
Ensure brevity in your answer.  1.07. What is the ratio of the Aid flow (current US$) of OECD members in 1971 to that in 1972?
Your response must be concise. 2.43. What is the ratio of the Aid flow (current US$) of Tunisia in 1971 to that in 1972?
Give a very brief answer. 0.45. What is the ratio of the Aid flow (current US$) of Caribbean small states in 1971 to that in 1973?
Your answer should be compact. 0.85. What is the ratio of the Aid flow (current US$) of OECD members in 1971 to that in 1973?
Your answer should be compact. 1.02. What is the ratio of the Aid flow (current US$) of El Salvador in 1971 to that in 1973?
Your response must be concise. 3.33. What is the ratio of the Aid flow (current US$) of Tunisia in 1971 to that in 1973?
Provide a succinct answer. 0.53. What is the ratio of the Aid flow (current US$) of Caribbean small states in 1971 to that in 1974?
Your answer should be compact. 0.65. What is the ratio of the Aid flow (current US$) of OECD members in 1971 to that in 1974?
Keep it short and to the point. 1.2. What is the ratio of the Aid flow (current US$) of El Salvador in 1971 to that in 1974?
Ensure brevity in your answer.  0.25. What is the ratio of the Aid flow (current US$) in Tunisia in 1971 to that in 1974?
Your response must be concise. 0.49. What is the ratio of the Aid flow (current US$) in Caribbean small states in 1972 to that in 1973?
Keep it short and to the point. 0.8. What is the ratio of the Aid flow (current US$) of OECD members in 1972 to that in 1973?
Offer a very short reply. 0.42. What is the ratio of the Aid flow (current US$) in El Salvador in 1972 to that in 1973?
Keep it short and to the point. 0.44. What is the ratio of the Aid flow (current US$) of Tunisia in 1972 to that in 1973?
Provide a succinct answer. 1.18. What is the ratio of the Aid flow (current US$) in Caribbean small states in 1972 to that in 1974?
Offer a very short reply. 0.61. What is the ratio of the Aid flow (current US$) of OECD members in 1972 to that in 1974?
Offer a terse response. 0.49. What is the ratio of the Aid flow (current US$) of El Salvador in 1972 to that in 1974?
Your answer should be compact. 0.03. What is the ratio of the Aid flow (current US$) in Tunisia in 1972 to that in 1974?
Offer a terse response. 1.1. What is the ratio of the Aid flow (current US$) in Caribbean small states in 1973 to that in 1974?
Ensure brevity in your answer.  0.76. What is the ratio of the Aid flow (current US$) in OECD members in 1973 to that in 1974?
Offer a very short reply. 1.18. What is the ratio of the Aid flow (current US$) of El Salvador in 1973 to that in 1974?
Make the answer very short. 0.07. What is the ratio of the Aid flow (current US$) in Tunisia in 1973 to that in 1974?
Provide a succinct answer. 0.94. What is the difference between the highest and the second highest Aid flow (current US$) of Caribbean small states?
Offer a very short reply. 3.34e+06. What is the difference between the highest and the second highest Aid flow (current US$) of OECD members?
Keep it short and to the point. 1.59e+06. What is the difference between the highest and the second highest Aid flow (current US$) of El Salvador?
Your answer should be very brief. 7.00e+04. What is the difference between the highest and the second highest Aid flow (current US$) in Tunisia?
Keep it short and to the point. 1.25e+06. What is the difference between the highest and the lowest Aid flow (current US$) in Caribbean small states?
Your answer should be compact. 6.63e+06. What is the difference between the highest and the lowest Aid flow (current US$) of OECD members?
Offer a very short reply. 7.05e+06. What is the difference between the highest and the lowest Aid flow (current US$) in El Salvador?
Your answer should be compact. 1.44e+06. What is the difference between the highest and the lowest Aid flow (current US$) of Tunisia?
Ensure brevity in your answer.  1.00e+07. 